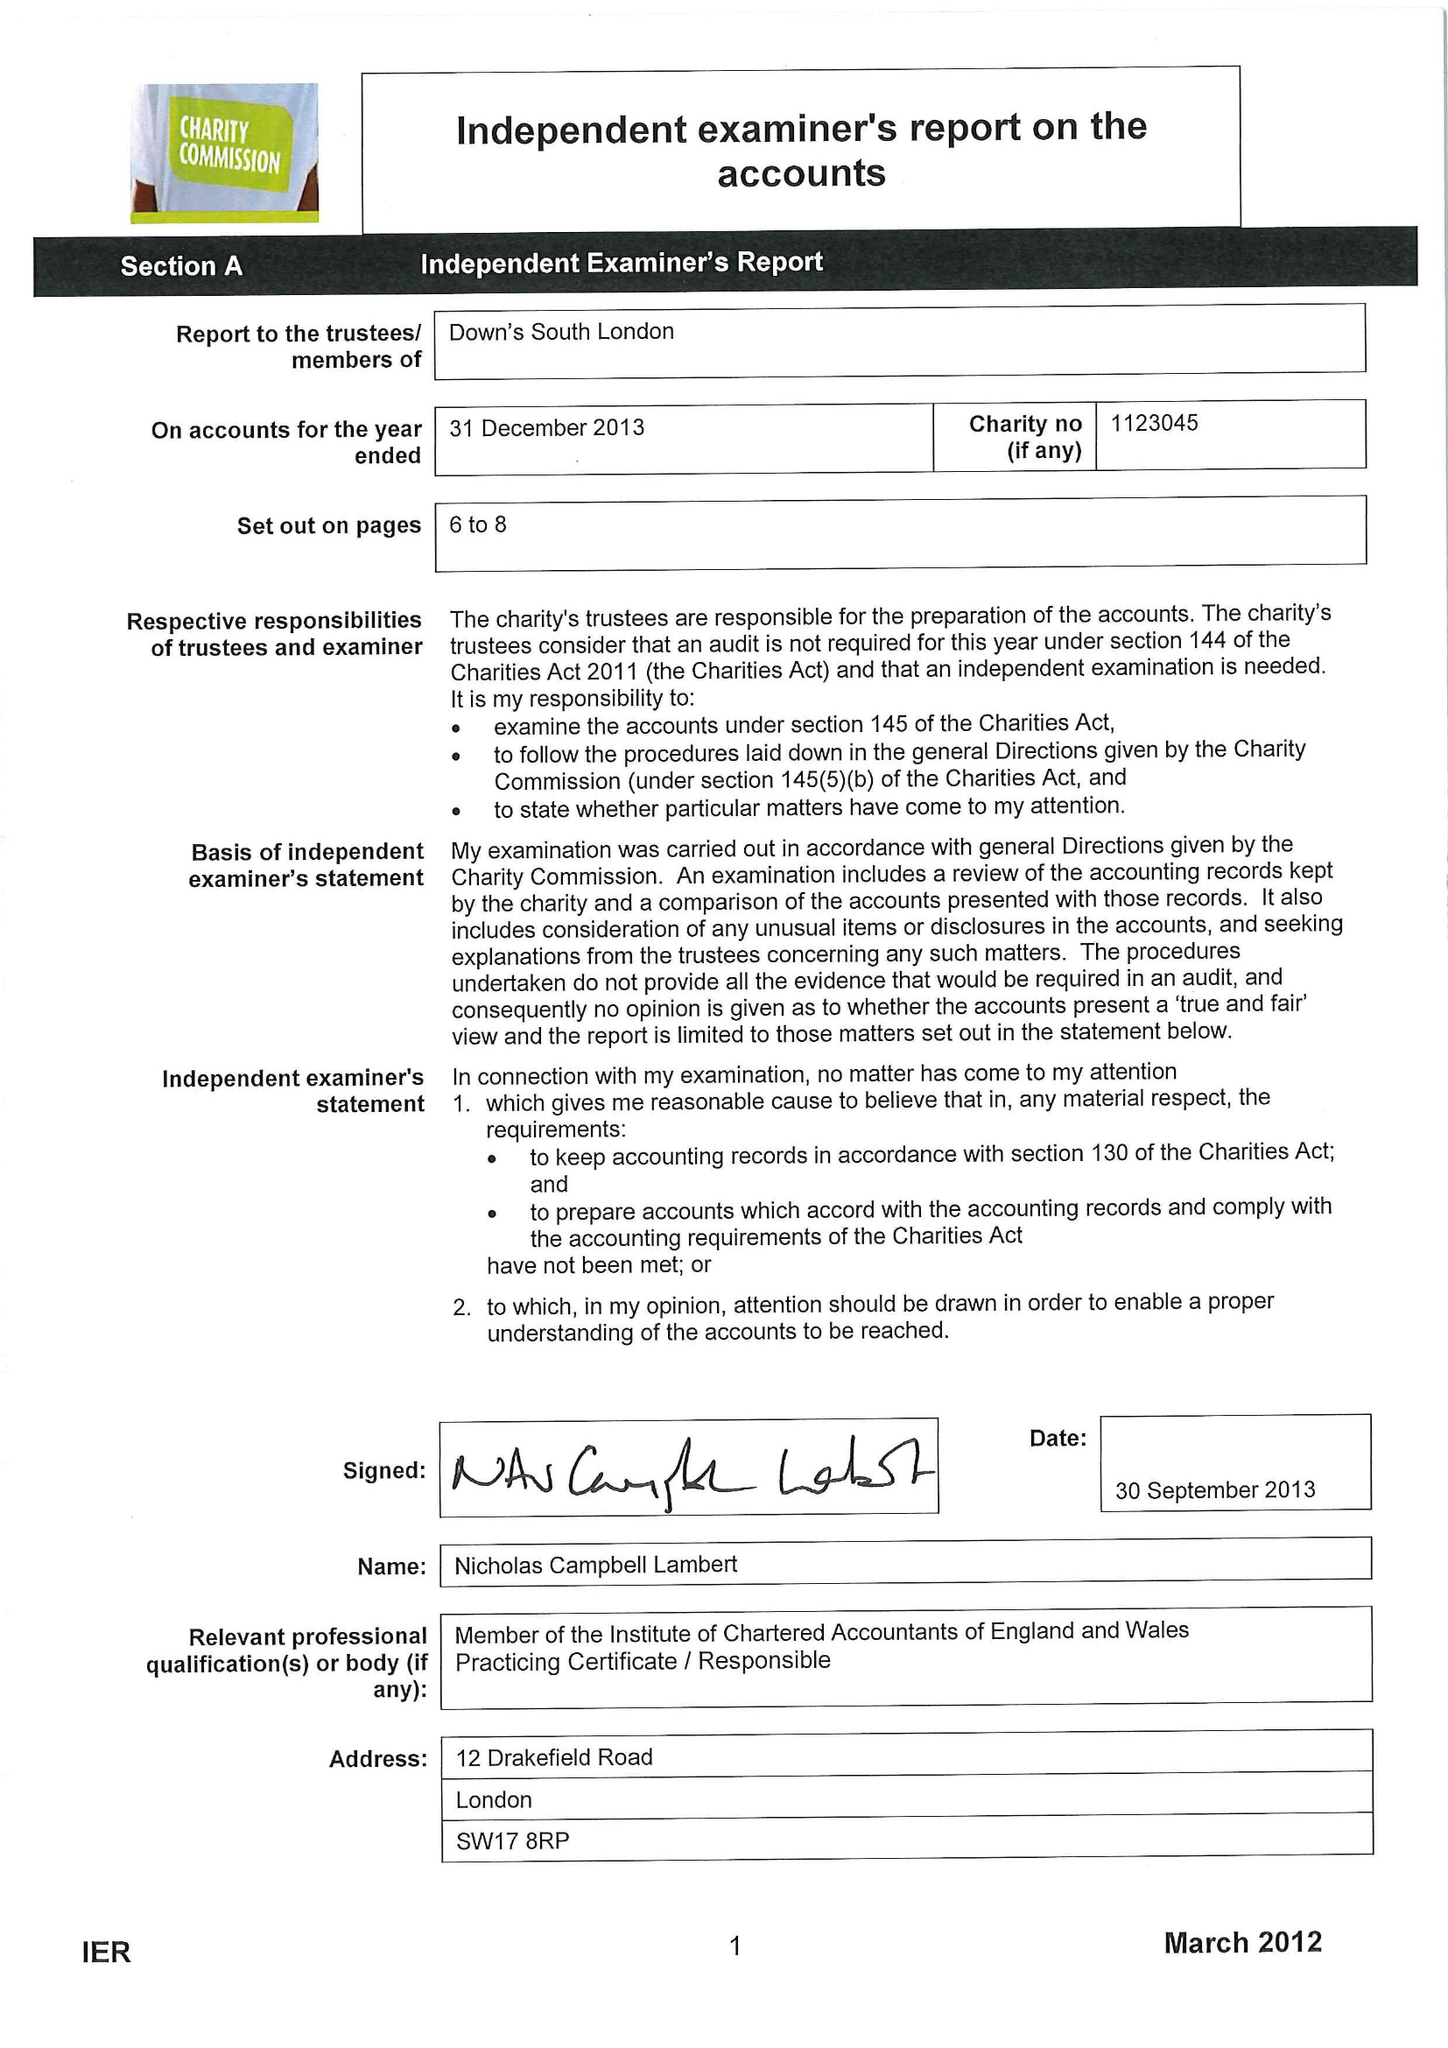What is the value for the charity_number?
Answer the question using a single word or phrase. 1123045 